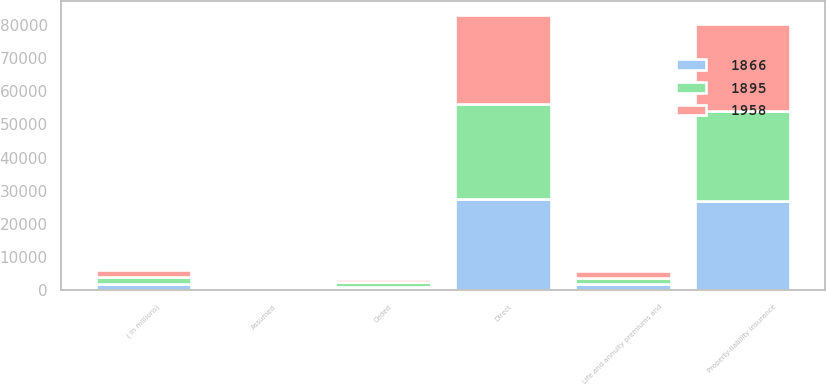Convert chart to OTSL. <chart><loc_0><loc_0><loc_500><loc_500><stacked_bar_chart><ecel><fcel>( in millions)<fcel>Direct<fcel>Assumed<fcel>Ceded<fcel>Property-liability insurance<fcel>Life and annuity premiums and<nl><fcel>1958<fcel>2009<fcel>26980<fcel>41<fcel>1050<fcel>26194<fcel>1958<nl><fcel>1866<fcel>2008<fcel>27667<fcel>85<fcel>1168<fcel>26967<fcel>1895<nl><fcel>1895<fcel>2007<fcel>28423<fcel>59<fcel>1299<fcel>27233<fcel>1866<nl></chart> 